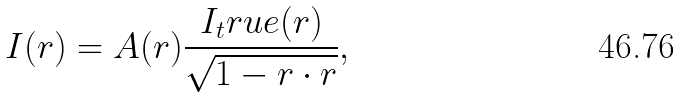Convert formula to latex. <formula><loc_0><loc_0><loc_500><loc_500>I ( r ) = A ( r ) \frac { I _ { t } r u e ( r ) } { \sqrt { 1 - r \cdot r } } ,</formula> 